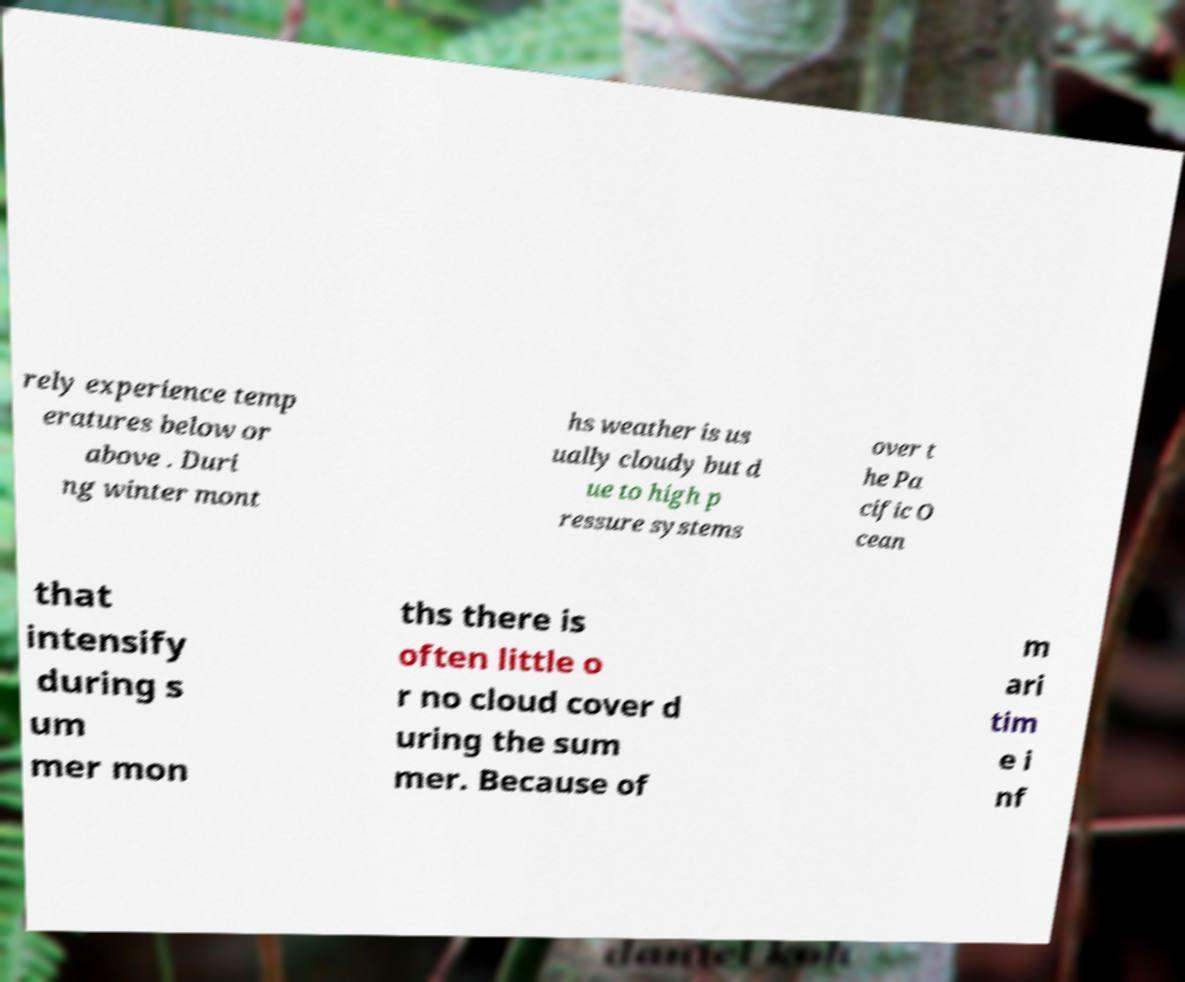Please read and relay the text visible in this image. What does it say? rely experience temp eratures below or above . Duri ng winter mont hs weather is us ually cloudy but d ue to high p ressure systems over t he Pa cific O cean that intensify during s um mer mon ths there is often little o r no cloud cover d uring the sum mer. Because of m ari tim e i nf 